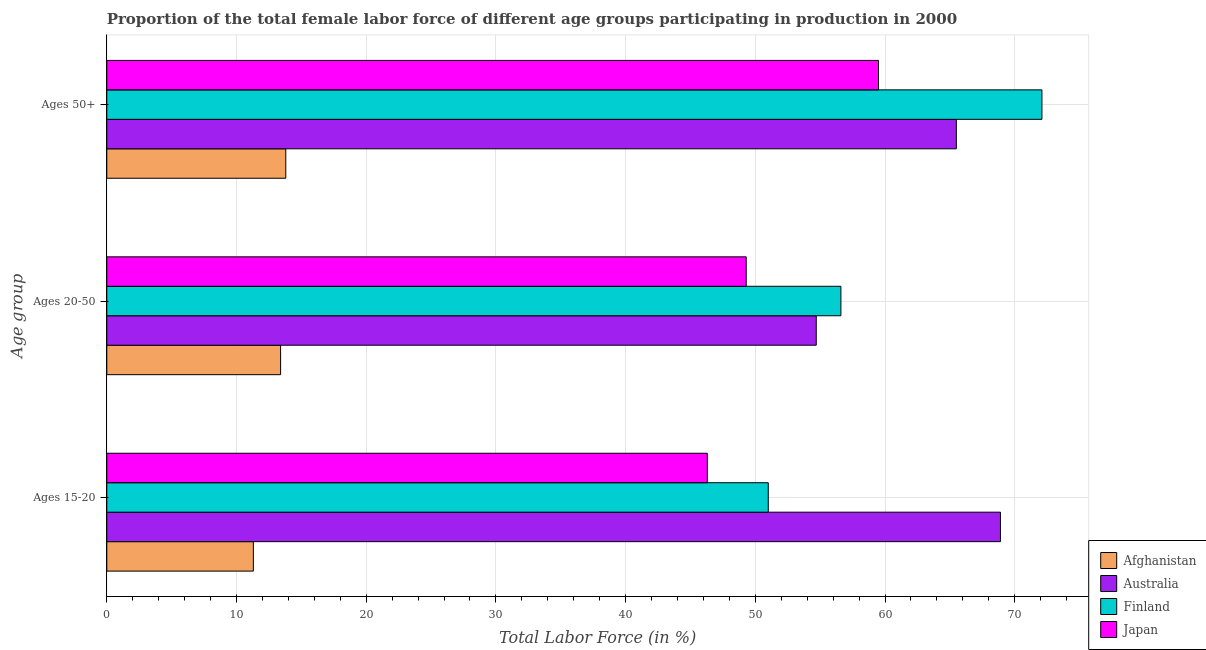How many groups of bars are there?
Ensure brevity in your answer.  3. What is the label of the 2nd group of bars from the top?
Offer a very short reply. Ages 20-50. What is the percentage of female labor force within the age group 15-20 in Afghanistan?
Provide a short and direct response. 11.3. Across all countries, what is the maximum percentage of female labor force within the age group 20-50?
Give a very brief answer. 56.6. Across all countries, what is the minimum percentage of female labor force within the age group 15-20?
Your answer should be very brief. 11.3. In which country was the percentage of female labor force within the age group 15-20 minimum?
Provide a succinct answer. Afghanistan. What is the total percentage of female labor force within the age group 20-50 in the graph?
Ensure brevity in your answer.  174. What is the difference between the percentage of female labor force within the age group 20-50 in Japan and that in Afghanistan?
Your answer should be very brief. 35.9. What is the difference between the percentage of female labor force within the age group 20-50 in Australia and the percentage of female labor force above age 50 in Finland?
Offer a terse response. -17.4. What is the average percentage of female labor force above age 50 per country?
Your answer should be compact. 52.72. What is the difference between the percentage of female labor force within the age group 15-20 and percentage of female labor force above age 50 in Australia?
Give a very brief answer. 3.4. In how many countries, is the percentage of female labor force above age 50 greater than 48 %?
Provide a short and direct response. 3. What is the ratio of the percentage of female labor force within the age group 20-50 in Australia to that in Afghanistan?
Offer a terse response. 4.08. Is the percentage of female labor force within the age group 15-20 in Japan less than that in Afghanistan?
Keep it short and to the point. No. Is the difference between the percentage of female labor force above age 50 in Japan and Afghanistan greater than the difference between the percentage of female labor force within the age group 20-50 in Japan and Afghanistan?
Ensure brevity in your answer.  Yes. What is the difference between the highest and the second highest percentage of female labor force within the age group 15-20?
Provide a succinct answer. 17.9. What is the difference between the highest and the lowest percentage of female labor force above age 50?
Your response must be concise. 58.3. What does the 4th bar from the top in Ages 15-20 represents?
Your answer should be very brief. Afghanistan. What does the 3rd bar from the bottom in Ages 50+ represents?
Offer a very short reply. Finland. Are the values on the major ticks of X-axis written in scientific E-notation?
Offer a very short reply. No. Does the graph contain any zero values?
Ensure brevity in your answer.  No. Where does the legend appear in the graph?
Ensure brevity in your answer.  Bottom right. How many legend labels are there?
Provide a short and direct response. 4. How are the legend labels stacked?
Your response must be concise. Vertical. What is the title of the graph?
Make the answer very short. Proportion of the total female labor force of different age groups participating in production in 2000. What is the label or title of the Y-axis?
Make the answer very short. Age group. What is the Total Labor Force (in %) in Afghanistan in Ages 15-20?
Offer a terse response. 11.3. What is the Total Labor Force (in %) of Australia in Ages 15-20?
Keep it short and to the point. 68.9. What is the Total Labor Force (in %) in Japan in Ages 15-20?
Offer a very short reply. 46.3. What is the Total Labor Force (in %) of Afghanistan in Ages 20-50?
Offer a very short reply. 13.4. What is the Total Labor Force (in %) of Australia in Ages 20-50?
Make the answer very short. 54.7. What is the Total Labor Force (in %) in Finland in Ages 20-50?
Keep it short and to the point. 56.6. What is the Total Labor Force (in %) in Japan in Ages 20-50?
Ensure brevity in your answer.  49.3. What is the Total Labor Force (in %) of Afghanistan in Ages 50+?
Keep it short and to the point. 13.8. What is the Total Labor Force (in %) in Australia in Ages 50+?
Your answer should be compact. 65.5. What is the Total Labor Force (in %) in Finland in Ages 50+?
Provide a short and direct response. 72.1. What is the Total Labor Force (in %) of Japan in Ages 50+?
Offer a very short reply. 59.5. Across all Age group, what is the maximum Total Labor Force (in %) in Afghanistan?
Offer a terse response. 13.8. Across all Age group, what is the maximum Total Labor Force (in %) in Australia?
Your answer should be compact. 68.9. Across all Age group, what is the maximum Total Labor Force (in %) of Finland?
Your answer should be very brief. 72.1. Across all Age group, what is the maximum Total Labor Force (in %) of Japan?
Your response must be concise. 59.5. Across all Age group, what is the minimum Total Labor Force (in %) in Afghanistan?
Offer a very short reply. 11.3. Across all Age group, what is the minimum Total Labor Force (in %) of Australia?
Offer a very short reply. 54.7. Across all Age group, what is the minimum Total Labor Force (in %) of Finland?
Give a very brief answer. 51. Across all Age group, what is the minimum Total Labor Force (in %) of Japan?
Offer a terse response. 46.3. What is the total Total Labor Force (in %) of Afghanistan in the graph?
Keep it short and to the point. 38.5. What is the total Total Labor Force (in %) of Australia in the graph?
Your response must be concise. 189.1. What is the total Total Labor Force (in %) in Finland in the graph?
Provide a succinct answer. 179.7. What is the total Total Labor Force (in %) in Japan in the graph?
Your response must be concise. 155.1. What is the difference between the Total Labor Force (in %) in Afghanistan in Ages 15-20 and that in Ages 20-50?
Your response must be concise. -2.1. What is the difference between the Total Labor Force (in %) of Afghanistan in Ages 15-20 and that in Ages 50+?
Ensure brevity in your answer.  -2.5. What is the difference between the Total Labor Force (in %) of Australia in Ages 15-20 and that in Ages 50+?
Offer a terse response. 3.4. What is the difference between the Total Labor Force (in %) in Finland in Ages 15-20 and that in Ages 50+?
Your response must be concise. -21.1. What is the difference between the Total Labor Force (in %) in Japan in Ages 15-20 and that in Ages 50+?
Your answer should be compact. -13.2. What is the difference between the Total Labor Force (in %) of Australia in Ages 20-50 and that in Ages 50+?
Your answer should be very brief. -10.8. What is the difference between the Total Labor Force (in %) of Finland in Ages 20-50 and that in Ages 50+?
Provide a succinct answer. -15.5. What is the difference between the Total Labor Force (in %) of Japan in Ages 20-50 and that in Ages 50+?
Keep it short and to the point. -10.2. What is the difference between the Total Labor Force (in %) of Afghanistan in Ages 15-20 and the Total Labor Force (in %) of Australia in Ages 20-50?
Offer a terse response. -43.4. What is the difference between the Total Labor Force (in %) of Afghanistan in Ages 15-20 and the Total Labor Force (in %) of Finland in Ages 20-50?
Your answer should be compact. -45.3. What is the difference between the Total Labor Force (in %) of Afghanistan in Ages 15-20 and the Total Labor Force (in %) of Japan in Ages 20-50?
Give a very brief answer. -38. What is the difference between the Total Labor Force (in %) in Australia in Ages 15-20 and the Total Labor Force (in %) in Finland in Ages 20-50?
Your response must be concise. 12.3. What is the difference between the Total Labor Force (in %) of Australia in Ages 15-20 and the Total Labor Force (in %) of Japan in Ages 20-50?
Your response must be concise. 19.6. What is the difference between the Total Labor Force (in %) in Afghanistan in Ages 15-20 and the Total Labor Force (in %) in Australia in Ages 50+?
Provide a short and direct response. -54.2. What is the difference between the Total Labor Force (in %) of Afghanistan in Ages 15-20 and the Total Labor Force (in %) of Finland in Ages 50+?
Offer a very short reply. -60.8. What is the difference between the Total Labor Force (in %) of Afghanistan in Ages 15-20 and the Total Labor Force (in %) of Japan in Ages 50+?
Your answer should be very brief. -48.2. What is the difference between the Total Labor Force (in %) in Australia in Ages 15-20 and the Total Labor Force (in %) in Finland in Ages 50+?
Your answer should be very brief. -3.2. What is the difference between the Total Labor Force (in %) of Australia in Ages 15-20 and the Total Labor Force (in %) of Japan in Ages 50+?
Your answer should be very brief. 9.4. What is the difference between the Total Labor Force (in %) of Finland in Ages 15-20 and the Total Labor Force (in %) of Japan in Ages 50+?
Offer a very short reply. -8.5. What is the difference between the Total Labor Force (in %) of Afghanistan in Ages 20-50 and the Total Labor Force (in %) of Australia in Ages 50+?
Give a very brief answer. -52.1. What is the difference between the Total Labor Force (in %) of Afghanistan in Ages 20-50 and the Total Labor Force (in %) of Finland in Ages 50+?
Provide a succinct answer. -58.7. What is the difference between the Total Labor Force (in %) in Afghanistan in Ages 20-50 and the Total Labor Force (in %) in Japan in Ages 50+?
Offer a terse response. -46.1. What is the difference between the Total Labor Force (in %) of Australia in Ages 20-50 and the Total Labor Force (in %) of Finland in Ages 50+?
Your answer should be compact. -17.4. What is the difference between the Total Labor Force (in %) of Finland in Ages 20-50 and the Total Labor Force (in %) of Japan in Ages 50+?
Your answer should be compact. -2.9. What is the average Total Labor Force (in %) of Afghanistan per Age group?
Offer a terse response. 12.83. What is the average Total Labor Force (in %) in Australia per Age group?
Your answer should be very brief. 63.03. What is the average Total Labor Force (in %) of Finland per Age group?
Offer a very short reply. 59.9. What is the average Total Labor Force (in %) of Japan per Age group?
Your answer should be compact. 51.7. What is the difference between the Total Labor Force (in %) of Afghanistan and Total Labor Force (in %) of Australia in Ages 15-20?
Give a very brief answer. -57.6. What is the difference between the Total Labor Force (in %) in Afghanistan and Total Labor Force (in %) in Finland in Ages 15-20?
Ensure brevity in your answer.  -39.7. What is the difference between the Total Labor Force (in %) of Afghanistan and Total Labor Force (in %) of Japan in Ages 15-20?
Offer a terse response. -35. What is the difference between the Total Labor Force (in %) of Australia and Total Labor Force (in %) of Japan in Ages 15-20?
Offer a very short reply. 22.6. What is the difference between the Total Labor Force (in %) in Finland and Total Labor Force (in %) in Japan in Ages 15-20?
Provide a succinct answer. 4.7. What is the difference between the Total Labor Force (in %) of Afghanistan and Total Labor Force (in %) of Australia in Ages 20-50?
Make the answer very short. -41.3. What is the difference between the Total Labor Force (in %) of Afghanistan and Total Labor Force (in %) of Finland in Ages 20-50?
Your answer should be very brief. -43.2. What is the difference between the Total Labor Force (in %) in Afghanistan and Total Labor Force (in %) in Japan in Ages 20-50?
Your response must be concise. -35.9. What is the difference between the Total Labor Force (in %) in Australia and Total Labor Force (in %) in Japan in Ages 20-50?
Provide a short and direct response. 5.4. What is the difference between the Total Labor Force (in %) of Afghanistan and Total Labor Force (in %) of Australia in Ages 50+?
Provide a succinct answer. -51.7. What is the difference between the Total Labor Force (in %) of Afghanistan and Total Labor Force (in %) of Finland in Ages 50+?
Provide a succinct answer. -58.3. What is the difference between the Total Labor Force (in %) in Afghanistan and Total Labor Force (in %) in Japan in Ages 50+?
Your response must be concise. -45.7. What is the difference between the Total Labor Force (in %) in Australia and Total Labor Force (in %) in Finland in Ages 50+?
Make the answer very short. -6.6. What is the ratio of the Total Labor Force (in %) of Afghanistan in Ages 15-20 to that in Ages 20-50?
Offer a very short reply. 0.84. What is the ratio of the Total Labor Force (in %) of Australia in Ages 15-20 to that in Ages 20-50?
Provide a short and direct response. 1.26. What is the ratio of the Total Labor Force (in %) of Finland in Ages 15-20 to that in Ages 20-50?
Ensure brevity in your answer.  0.9. What is the ratio of the Total Labor Force (in %) in Japan in Ages 15-20 to that in Ages 20-50?
Your response must be concise. 0.94. What is the ratio of the Total Labor Force (in %) of Afghanistan in Ages 15-20 to that in Ages 50+?
Offer a terse response. 0.82. What is the ratio of the Total Labor Force (in %) of Australia in Ages 15-20 to that in Ages 50+?
Offer a very short reply. 1.05. What is the ratio of the Total Labor Force (in %) of Finland in Ages 15-20 to that in Ages 50+?
Provide a short and direct response. 0.71. What is the ratio of the Total Labor Force (in %) of Japan in Ages 15-20 to that in Ages 50+?
Provide a succinct answer. 0.78. What is the ratio of the Total Labor Force (in %) of Australia in Ages 20-50 to that in Ages 50+?
Give a very brief answer. 0.84. What is the ratio of the Total Labor Force (in %) in Finland in Ages 20-50 to that in Ages 50+?
Offer a terse response. 0.79. What is the ratio of the Total Labor Force (in %) of Japan in Ages 20-50 to that in Ages 50+?
Offer a terse response. 0.83. What is the difference between the highest and the second highest Total Labor Force (in %) in Afghanistan?
Your response must be concise. 0.4. What is the difference between the highest and the second highest Total Labor Force (in %) of Australia?
Your answer should be very brief. 3.4. What is the difference between the highest and the second highest Total Labor Force (in %) in Finland?
Make the answer very short. 15.5. What is the difference between the highest and the lowest Total Labor Force (in %) of Australia?
Ensure brevity in your answer.  14.2. What is the difference between the highest and the lowest Total Labor Force (in %) in Finland?
Provide a succinct answer. 21.1. What is the difference between the highest and the lowest Total Labor Force (in %) of Japan?
Ensure brevity in your answer.  13.2. 